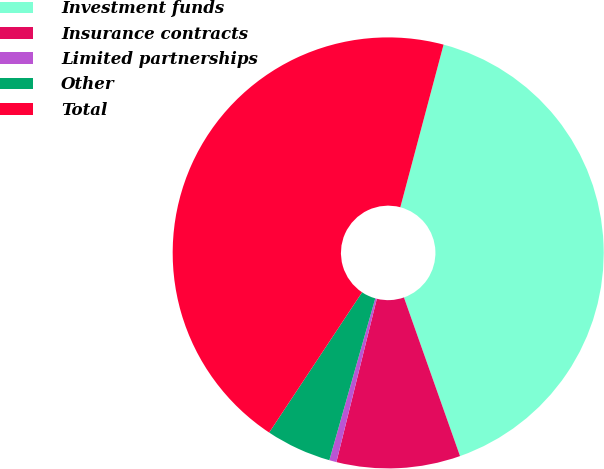<chart> <loc_0><loc_0><loc_500><loc_500><pie_chart><fcel>Investment funds<fcel>Insurance contracts<fcel>Limited partnerships<fcel>Other<fcel>Total<nl><fcel>40.45%<fcel>9.27%<fcel>0.54%<fcel>4.91%<fcel>44.82%<nl></chart> 